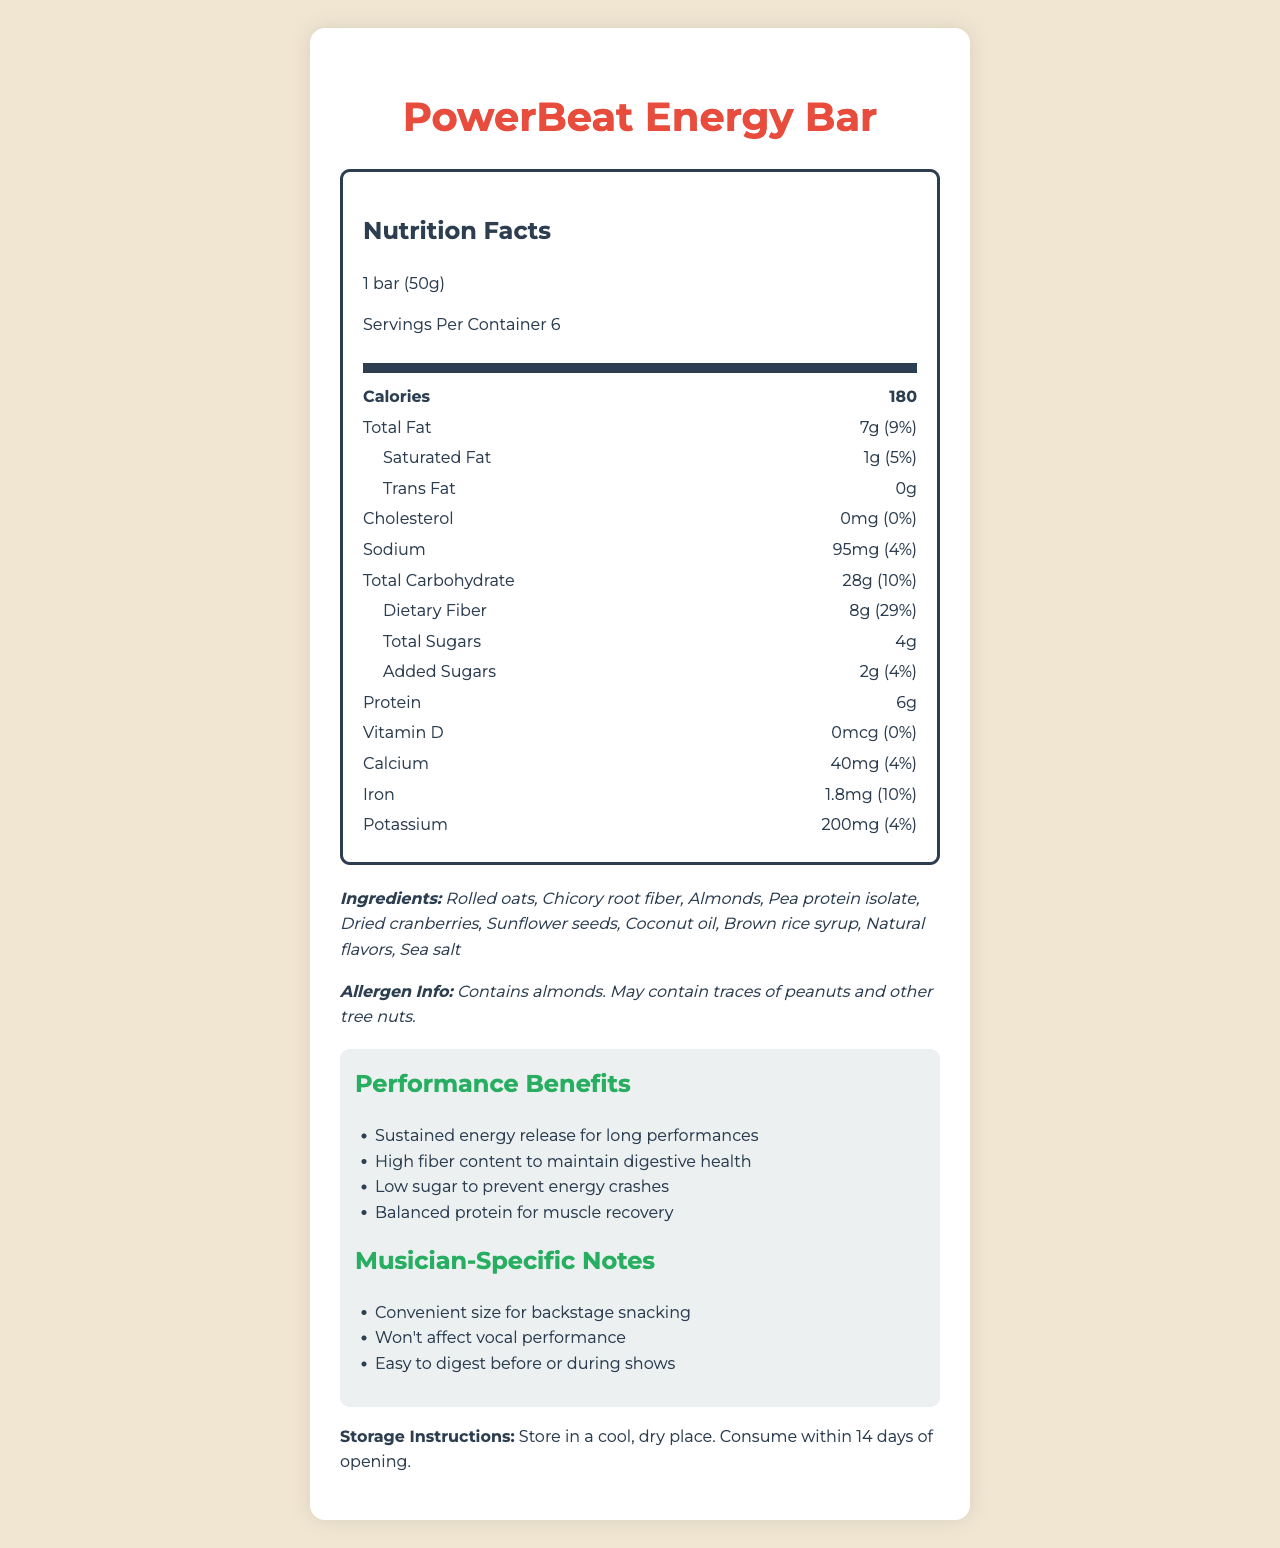what is the serving size of the PowerBeat Energy Bar? The document specifies that the serving size is "1 bar (50g)".
Answer: 1 bar (50g) How many calories are in one serving of the PowerBeat Energy Bar? The Nutrition Facts section of the document lists 180 calories per serving.
Answer: 180 What is the total fat content in one serving of the PowerBeat Energy Bar? The document lists the total fat content as 7g.
Answer: 7g How much dietary fiber is in one serving and its percent daily value? The dietary fiber content is 8g, and this is 29% of the daily value.
Answer: 8g, 29% Is there any trans fat in the PowerBeat Energy Bar? The document lists 0g of trans fat, indicating there is no trans fat in the product.
Answer: No What is the amount of protein per serving of the PowerBeat Energy Bar? According to the document, the protein content per serving is 6g.
Answer: 6g Which ingredient is not found in the PowerBeat Energy Bar? A. Almonds B. Peanuts C. Dried cranberries D. Sea salt Almonds, dried cranberries, and sea salt are listed in the ingredients, but peanuts are not.
Answer: B. Peanuts What performance benefit is claimed by the PowerBeat Energy Bar? A. High sugar content for quick energy B. Balanced protein for muscle recovery C. Low fiber for easier digestion One of the performance benefits listed is "Balanced protein for muscle recovery."
Answer: B. Balanced protein for muscle recovery Does the PowerBeat Energy Bar contain vitamin D? Vitamin D is listed as 0mcg, which means the bar does not contain any vitamin D.
Answer: No What should be the storage condition for the PowerBeat Energy Bar? The storage instructions section specifies these conditions.
Answer: Store in a cool, dry place. Consume within 14 days of opening. Summarize the Nutrition Facts label and additional information of the PowerBeat Energy Bar. The document provides detailed nutritional information, ingredients, allergen information, performance benefits, musician-specific notes, and storage instructions, highlighting the product's suitability for maintaining energy during performances.
Answer: The PowerBeat Energy Bar is a low-sugar, high-fiber snack designed for sustained energy and digestive health. Each bar has 180 calories with 7g total fat, 28g total carbohydrates, including 8g of dietary fiber and 4g of sugars. It also contains 6g of protein. Key ingredients include rolled oats, chicory root fiber, and almonds. The bar is noted for sustaining energy, supporting digestive health, and muscle recovery. The product should be stored in a cool, dry place and consumed within 14 days of opening. What is the total carbohydrate content of the PowerBeat Energy Bar? The document lists the total carbohydrate content as 28g.
Answer: 28g What is the percent daily value of calcium in the PowerBeat Energy Bar? A. 10% B. 4% C. 29% D. 5% The percent daily value of calcium in the bar is listed as 4%.
Answer: B. 4% What are the first three ingredients listed for the PowerBeat Energy Bar? The first three ingredients listed are rolled oats, chicory root fiber, and almonds.
Answer: Rolled oats, Chicory root fiber, Almonds How often can the PowerBeat Energy Bar be consumed without affecting vocal performance? The document mentions it can be consumed before or during shows without affecting vocal performance.
Answer: Before or during shows What is the primary benefit related to sugar content in the PowerBeat Energy Bar? The document notes that the bar has low sugar content to prevent energy crashes.
Answer: Low sugar to prevent energy crashes Is there any information given about the vitamin B content in the PowerBeat Energy Bar? The document does not provide any information regarding vitamin B content.
Answer: Not enough information 